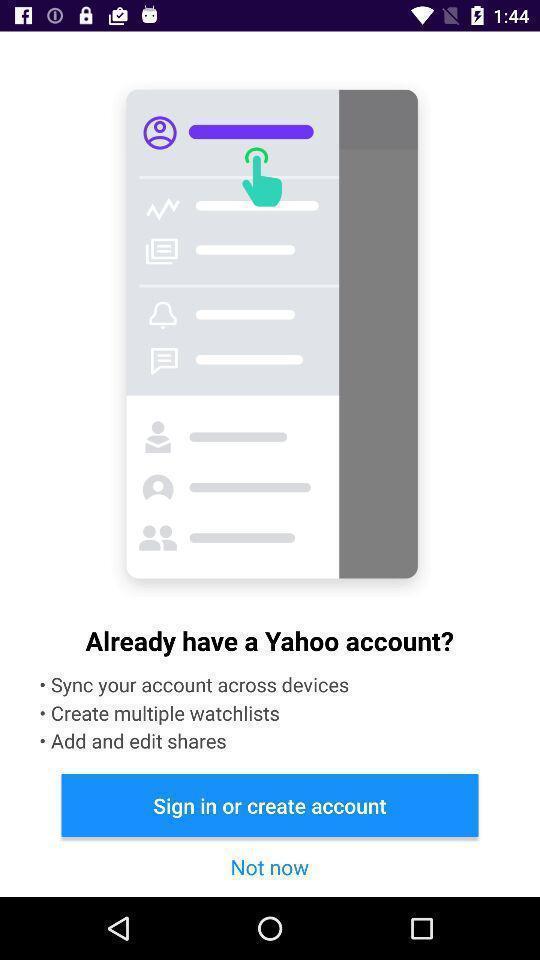What details can you identify in this image? Sign page for social app. 